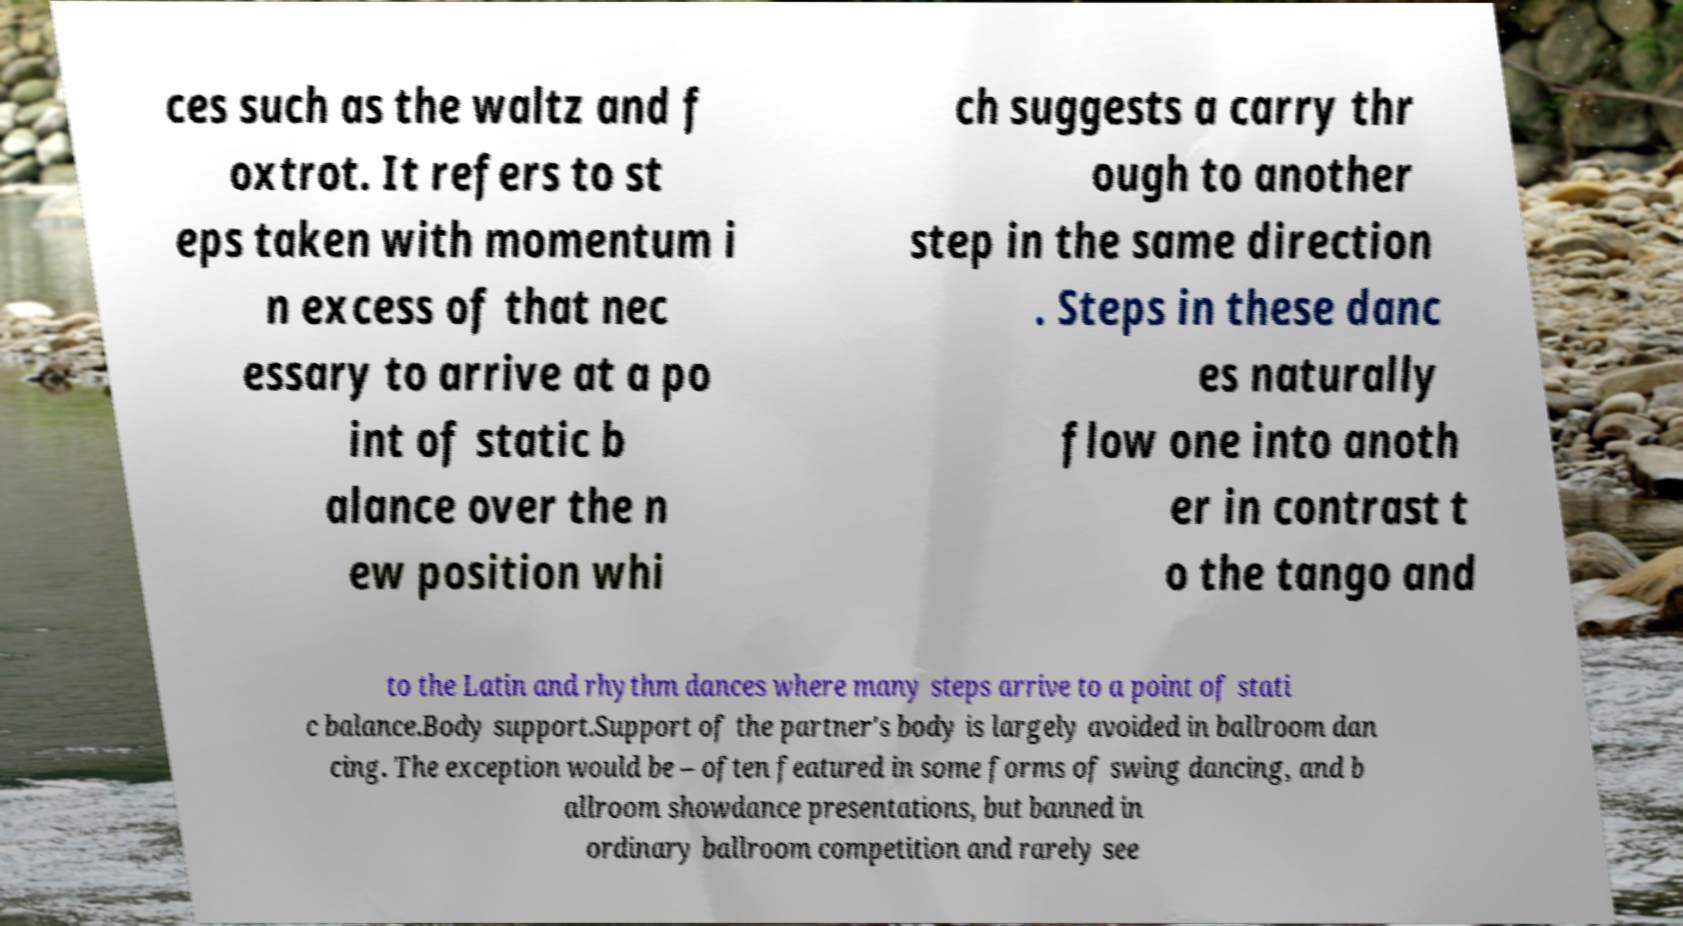For documentation purposes, I need the text within this image transcribed. Could you provide that? ces such as the waltz and f oxtrot. It refers to st eps taken with momentum i n excess of that nec essary to arrive at a po int of static b alance over the n ew position whi ch suggests a carry thr ough to another step in the same direction . Steps in these danc es naturally flow one into anoth er in contrast t o the tango and to the Latin and rhythm dances where many steps arrive to a point of stati c balance.Body support.Support of the partner's body is largely avoided in ballroom dan cing. The exception would be – often featured in some forms of swing dancing, and b allroom showdance presentations, but banned in ordinary ballroom competition and rarely see 